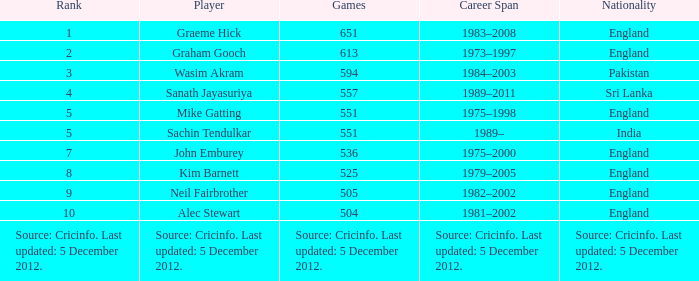What is the nationality of the player who played 505 games? England. 